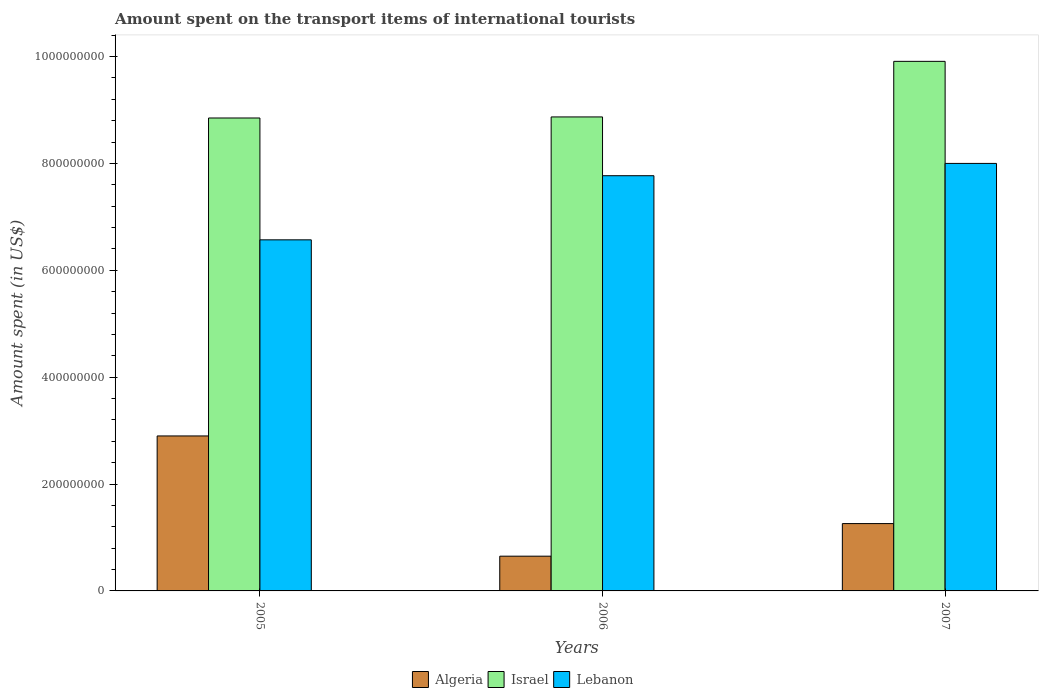How many different coloured bars are there?
Provide a short and direct response. 3. How many groups of bars are there?
Offer a very short reply. 3. Are the number of bars per tick equal to the number of legend labels?
Give a very brief answer. Yes. Are the number of bars on each tick of the X-axis equal?
Offer a terse response. Yes. What is the label of the 2nd group of bars from the left?
Your answer should be compact. 2006. What is the amount spent on the transport items of international tourists in Lebanon in 2006?
Keep it short and to the point. 7.77e+08. Across all years, what is the maximum amount spent on the transport items of international tourists in Lebanon?
Your answer should be very brief. 8.00e+08. Across all years, what is the minimum amount spent on the transport items of international tourists in Algeria?
Offer a terse response. 6.50e+07. In which year was the amount spent on the transport items of international tourists in Algeria maximum?
Ensure brevity in your answer.  2005. What is the total amount spent on the transport items of international tourists in Lebanon in the graph?
Make the answer very short. 2.23e+09. What is the difference between the amount spent on the transport items of international tourists in Israel in 2005 and that in 2007?
Keep it short and to the point. -1.06e+08. What is the difference between the amount spent on the transport items of international tourists in Algeria in 2007 and the amount spent on the transport items of international tourists in Lebanon in 2005?
Give a very brief answer. -5.31e+08. What is the average amount spent on the transport items of international tourists in Algeria per year?
Ensure brevity in your answer.  1.60e+08. In the year 2007, what is the difference between the amount spent on the transport items of international tourists in Lebanon and amount spent on the transport items of international tourists in Algeria?
Offer a very short reply. 6.74e+08. In how many years, is the amount spent on the transport items of international tourists in Israel greater than 200000000 US$?
Provide a succinct answer. 3. What is the ratio of the amount spent on the transport items of international tourists in Lebanon in 2005 to that in 2007?
Your answer should be very brief. 0.82. What is the difference between the highest and the second highest amount spent on the transport items of international tourists in Algeria?
Your answer should be very brief. 1.64e+08. What is the difference between the highest and the lowest amount spent on the transport items of international tourists in Israel?
Keep it short and to the point. 1.06e+08. In how many years, is the amount spent on the transport items of international tourists in Algeria greater than the average amount spent on the transport items of international tourists in Algeria taken over all years?
Your answer should be very brief. 1. What does the 2nd bar from the left in 2006 represents?
Make the answer very short. Israel. What does the 2nd bar from the right in 2006 represents?
Offer a terse response. Israel. Is it the case that in every year, the sum of the amount spent on the transport items of international tourists in Lebanon and amount spent on the transport items of international tourists in Algeria is greater than the amount spent on the transport items of international tourists in Israel?
Give a very brief answer. No. Are all the bars in the graph horizontal?
Provide a succinct answer. No. How many years are there in the graph?
Keep it short and to the point. 3. What is the difference between two consecutive major ticks on the Y-axis?
Provide a short and direct response. 2.00e+08. Does the graph contain any zero values?
Make the answer very short. No. Where does the legend appear in the graph?
Your response must be concise. Bottom center. What is the title of the graph?
Keep it short and to the point. Amount spent on the transport items of international tourists. What is the label or title of the Y-axis?
Your answer should be very brief. Amount spent (in US$). What is the Amount spent (in US$) of Algeria in 2005?
Make the answer very short. 2.90e+08. What is the Amount spent (in US$) of Israel in 2005?
Your answer should be very brief. 8.85e+08. What is the Amount spent (in US$) in Lebanon in 2005?
Your response must be concise. 6.57e+08. What is the Amount spent (in US$) in Algeria in 2006?
Give a very brief answer. 6.50e+07. What is the Amount spent (in US$) in Israel in 2006?
Provide a short and direct response. 8.87e+08. What is the Amount spent (in US$) of Lebanon in 2006?
Your response must be concise. 7.77e+08. What is the Amount spent (in US$) in Algeria in 2007?
Provide a succinct answer. 1.26e+08. What is the Amount spent (in US$) of Israel in 2007?
Give a very brief answer. 9.91e+08. What is the Amount spent (in US$) in Lebanon in 2007?
Offer a very short reply. 8.00e+08. Across all years, what is the maximum Amount spent (in US$) of Algeria?
Your answer should be compact. 2.90e+08. Across all years, what is the maximum Amount spent (in US$) of Israel?
Provide a short and direct response. 9.91e+08. Across all years, what is the maximum Amount spent (in US$) of Lebanon?
Offer a very short reply. 8.00e+08. Across all years, what is the minimum Amount spent (in US$) in Algeria?
Provide a short and direct response. 6.50e+07. Across all years, what is the minimum Amount spent (in US$) of Israel?
Ensure brevity in your answer.  8.85e+08. Across all years, what is the minimum Amount spent (in US$) in Lebanon?
Provide a succinct answer. 6.57e+08. What is the total Amount spent (in US$) in Algeria in the graph?
Provide a succinct answer. 4.81e+08. What is the total Amount spent (in US$) of Israel in the graph?
Provide a succinct answer. 2.76e+09. What is the total Amount spent (in US$) of Lebanon in the graph?
Your response must be concise. 2.23e+09. What is the difference between the Amount spent (in US$) in Algeria in 2005 and that in 2006?
Your answer should be compact. 2.25e+08. What is the difference between the Amount spent (in US$) in Israel in 2005 and that in 2006?
Your answer should be compact. -2.00e+06. What is the difference between the Amount spent (in US$) of Lebanon in 2005 and that in 2006?
Your response must be concise. -1.20e+08. What is the difference between the Amount spent (in US$) of Algeria in 2005 and that in 2007?
Your answer should be compact. 1.64e+08. What is the difference between the Amount spent (in US$) of Israel in 2005 and that in 2007?
Your answer should be compact. -1.06e+08. What is the difference between the Amount spent (in US$) of Lebanon in 2005 and that in 2007?
Ensure brevity in your answer.  -1.43e+08. What is the difference between the Amount spent (in US$) in Algeria in 2006 and that in 2007?
Your answer should be very brief. -6.10e+07. What is the difference between the Amount spent (in US$) of Israel in 2006 and that in 2007?
Your response must be concise. -1.04e+08. What is the difference between the Amount spent (in US$) of Lebanon in 2006 and that in 2007?
Offer a terse response. -2.30e+07. What is the difference between the Amount spent (in US$) in Algeria in 2005 and the Amount spent (in US$) in Israel in 2006?
Provide a succinct answer. -5.97e+08. What is the difference between the Amount spent (in US$) in Algeria in 2005 and the Amount spent (in US$) in Lebanon in 2006?
Your response must be concise. -4.87e+08. What is the difference between the Amount spent (in US$) in Israel in 2005 and the Amount spent (in US$) in Lebanon in 2006?
Ensure brevity in your answer.  1.08e+08. What is the difference between the Amount spent (in US$) of Algeria in 2005 and the Amount spent (in US$) of Israel in 2007?
Your answer should be compact. -7.01e+08. What is the difference between the Amount spent (in US$) of Algeria in 2005 and the Amount spent (in US$) of Lebanon in 2007?
Provide a short and direct response. -5.10e+08. What is the difference between the Amount spent (in US$) of Israel in 2005 and the Amount spent (in US$) of Lebanon in 2007?
Keep it short and to the point. 8.50e+07. What is the difference between the Amount spent (in US$) of Algeria in 2006 and the Amount spent (in US$) of Israel in 2007?
Ensure brevity in your answer.  -9.26e+08. What is the difference between the Amount spent (in US$) in Algeria in 2006 and the Amount spent (in US$) in Lebanon in 2007?
Offer a terse response. -7.35e+08. What is the difference between the Amount spent (in US$) in Israel in 2006 and the Amount spent (in US$) in Lebanon in 2007?
Ensure brevity in your answer.  8.70e+07. What is the average Amount spent (in US$) in Algeria per year?
Offer a terse response. 1.60e+08. What is the average Amount spent (in US$) in Israel per year?
Your answer should be compact. 9.21e+08. What is the average Amount spent (in US$) of Lebanon per year?
Make the answer very short. 7.45e+08. In the year 2005, what is the difference between the Amount spent (in US$) of Algeria and Amount spent (in US$) of Israel?
Offer a very short reply. -5.95e+08. In the year 2005, what is the difference between the Amount spent (in US$) in Algeria and Amount spent (in US$) in Lebanon?
Give a very brief answer. -3.67e+08. In the year 2005, what is the difference between the Amount spent (in US$) of Israel and Amount spent (in US$) of Lebanon?
Your answer should be compact. 2.28e+08. In the year 2006, what is the difference between the Amount spent (in US$) of Algeria and Amount spent (in US$) of Israel?
Provide a succinct answer. -8.22e+08. In the year 2006, what is the difference between the Amount spent (in US$) of Algeria and Amount spent (in US$) of Lebanon?
Offer a very short reply. -7.12e+08. In the year 2006, what is the difference between the Amount spent (in US$) of Israel and Amount spent (in US$) of Lebanon?
Provide a short and direct response. 1.10e+08. In the year 2007, what is the difference between the Amount spent (in US$) of Algeria and Amount spent (in US$) of Israel?
Offer a very short reply. -8.65e+08. In the year 2007, what is the difference between the Amount spent (in US$) in Algeria and Amount spent (in US$) in Lebanon?
Keep it short and to the point. -6.74e+08. In the year 2007, what is the difference between the Amount spent (in US$) of Israel and Amount spent (in US$) of Lebanon?
Give a very brief answer. 1.91e+08. What is the ratio of the Amount spent (in US$) in Algeria in 2005 to that in 2006?
Offer a very short reply. 4.46. What is the ratio of the Amount spent (in US$) in Lebanon in 2005 to that in 2006?
Your answer should be very brief. 0.85. What is the ratio of the Amount spent (in US$) of Algeria in 2005 to that in 2007?
Give a very brief answer. 2.3. What is the ratio of the Amount spent (in US$) in Israel in 2005 to that in 2007?
Give a very brief answer. 0.89. What is the ratio of the Amount spent (in US$) in Lebanon in 2005 to that in 2007?
Give a very brief answer. 0.82. What is the ratio of the Amount spent (in US$) of Algeria in 2006 to that in 2007?
Give a very brief answer. 0.52. What is the ratio of the Amount spent (in US$) of Israel in 2006 to that in 2007?
Your answer should be very brief. 0.9. What is the ratio of the Amount spent (in US$) in Lebanon in 2006 to that in 2007?
Ensure brevity in your answer.  0.97. What is the difference between the highest and the second highest Amount spent (in US$) in Algeria?
Offer a very short reply. 1.64e+08. What is the difference between the highest and the second highest Amount spent (in US$) of Israel?
Give a very brief answer. 1.04e+08. What is the difference between the highest and the second highest Amount spent (in US$) of Lebanon?
Ensure brevity in your answer.  2.30e+07. What is the difference between the highest and the lowest Amount spent (in US$) in Algeria?
Provide a short and direct response. 2.25e+08. What is the difference between the highest and the lowest Amount spent (in US$) in Israel?
Offer a very short reply. 1.06e+08. What is the difference between the highest and the lowest Amount spent (in US$) in Lebanon?
Provide a succinct answer. 1.43e+08. 